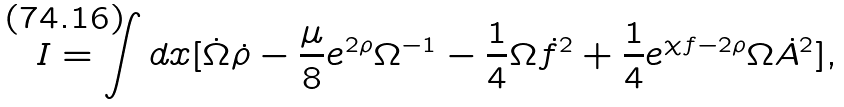<formula> <loc_0><loc_0><loc_500><loc_500>I = \int d x [ \dot { \Omega } \dot { \rho } - \frac { \mu } { 8 } e ^ { 2 \rho } \Omega ^ { - 1 } - \frac { 1 } { 4 } \Omega \dot { f } ^ { 2 } + \frac { 1 } { 4 } e ^ { \chi f - 2 \rho } \Omega \dot { A } ^ { 2 } ] ,</formula> 